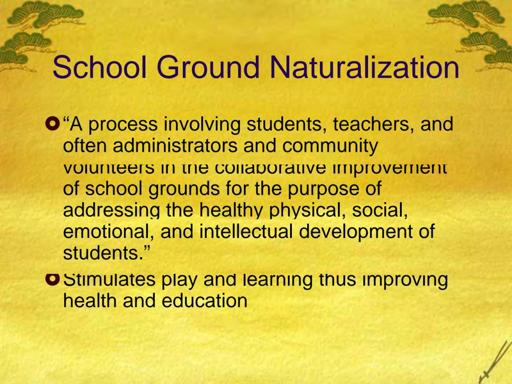What specific features might you find in a naturalized school ground? In a naturalized school ground, you are likely to find features such as native gardens, walking paths, outdoor classrooms, and various play areas that incorporate natural elements like wood and sand. There may also be rain gardens or small ponds to help students learn about aquatic ecosystems and water cycles, creating a rich, interactive environment for both learning and recreation. 